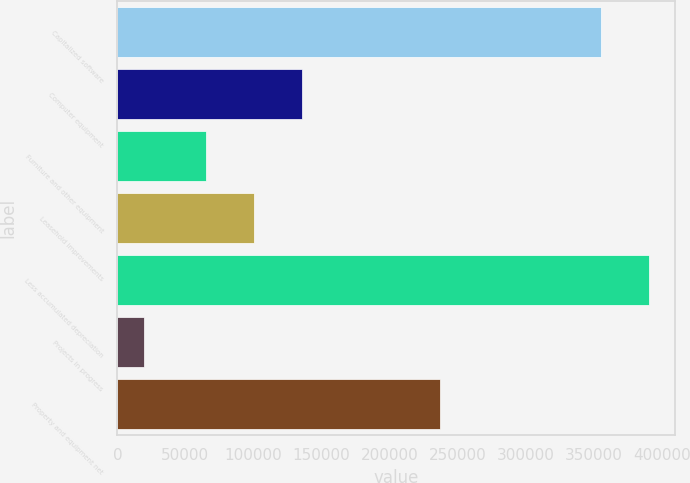<chart> <loc_0><loc_0><loc_500><loc_500><bar_chart><fcel>Capitalized software<fcel>Computer equipment<fcel>Furniture and other equipment<fcel>Leasehold improvements<fcel>Less accumulated depreciation<fcel>Projects in progress<fcel>Property and equipment net<nl><fcel>355088<fcel>135628<fcel>65098<fcel>100363<fcel>390353<fcel>19401<fcel>236820<nl></chart> 